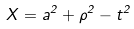<formula> <loc_0><loc_0><loc_500><loc_500>X = a ^ { 2 } + \rho ^ { 2 } - t ^ { 2 }</formula> 